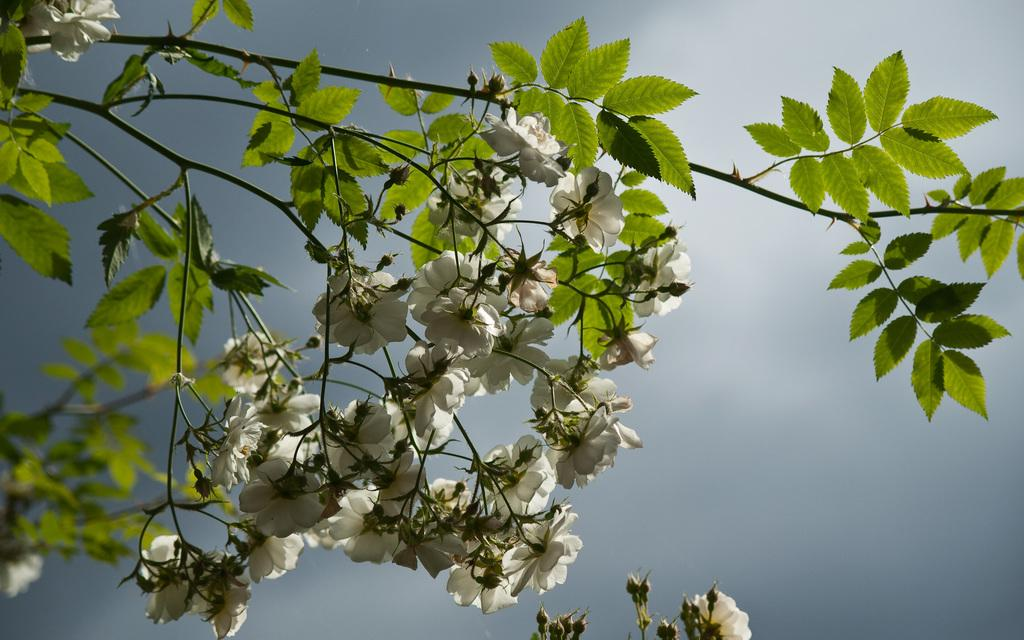What type of plant can be seen in the image? There is a tree in the image. What is the color of the tree in the image? The tree is green in color. What other type of plant can be seen in the image? There are flowers in the image. What is the color of the flowers in the image? The flowers are white in color. What can be seen in the background of the image? The sky is visible in the background of the image. How many passengers are sitting on the tree in the image? There are no passengers present in the image, as it features a tree and flowers. 